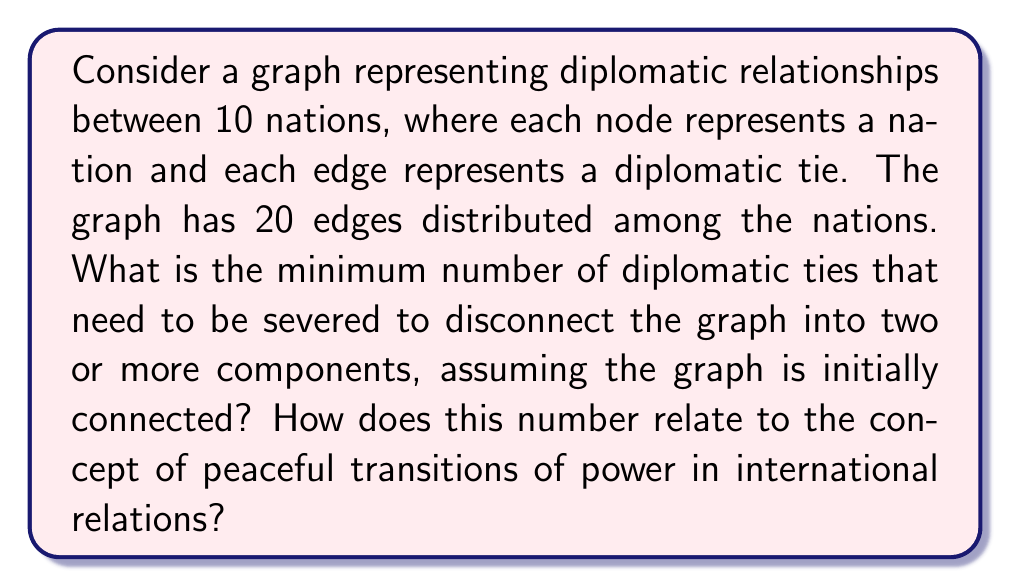Could you help me with this problem? To solve this problem, we need to understand the concept of edge connectivity in graph theory and its relation to diplomatic resilience.

1) First, let's recall that the edge connectivity of a graph, denoted as $\lambda(G)$, is the minimum number of edges that need to be removed to disconnect the graph.

2) For a graph with $n$ vertices, the maximum possible edge connectivity is $n-1$. This occurs in a complete graph where every vertex is connected to every other vertex.

3) In our case, we have $n = 10$ nations and $m = 20$ edges. The average degree of each vertex is:

   $$\frac{2m}{n} = \frac{2 \cdot 20}{10} = 4$$

4) The edge connectivity is always less than or equal to the minimum degree of the graph. In this case, some nations must have a degree less than 4 (as it's the average), so $\lambda(G) \leq 3$.

5) To find the exact value of $\lambda(G)$, we would need more information about the specific structure of the graph. However, we can deduce that $\lambda(G)$ must be at least 2, as if it were 1, the graph would not be optimally connected given the number of edges available.

6) Therefore, the minimum number of diplomatic ties that need to be severed to disconnect the graph is either 2 or 3.

7) In the context of peaceful transitions of power, this number represents the resilience of the international diplomatic network. A higher edge connectivity implies that more diplomatic relationships would need to be severed to isolate a nation or group of nations, which promotes stability and peaceful resolutions to conflicts.
Answer: The minimum number of diplomatic ties that need to be severed to disconnect the graph is either 2 or 3. This number, representing the edge connectivity $\lambda(G)$, indicates the resilience of the international diplomatic network, with higher values promoting more stable and peaceful transitions of power. 